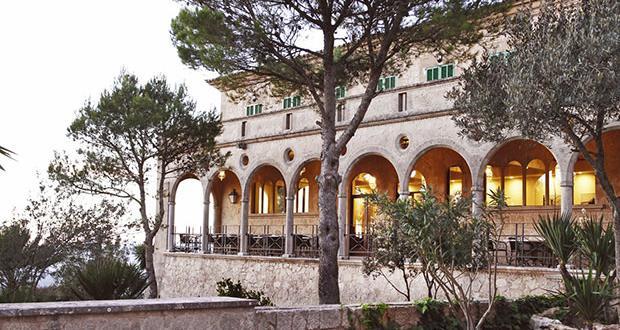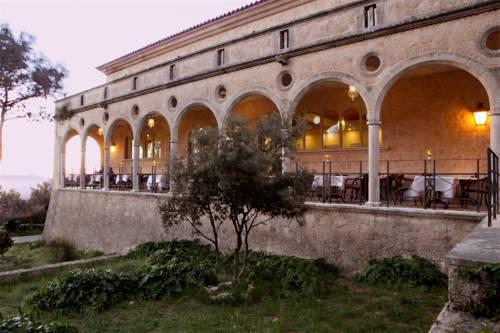The first image is the image on the left, the second image is the image on the right. Evaluate the accuracy of this statement regarding the images: "At least one image shows a seating area along a row of archways that overlooks a garden area.". Is it true? Answer yes or no. Yes. 